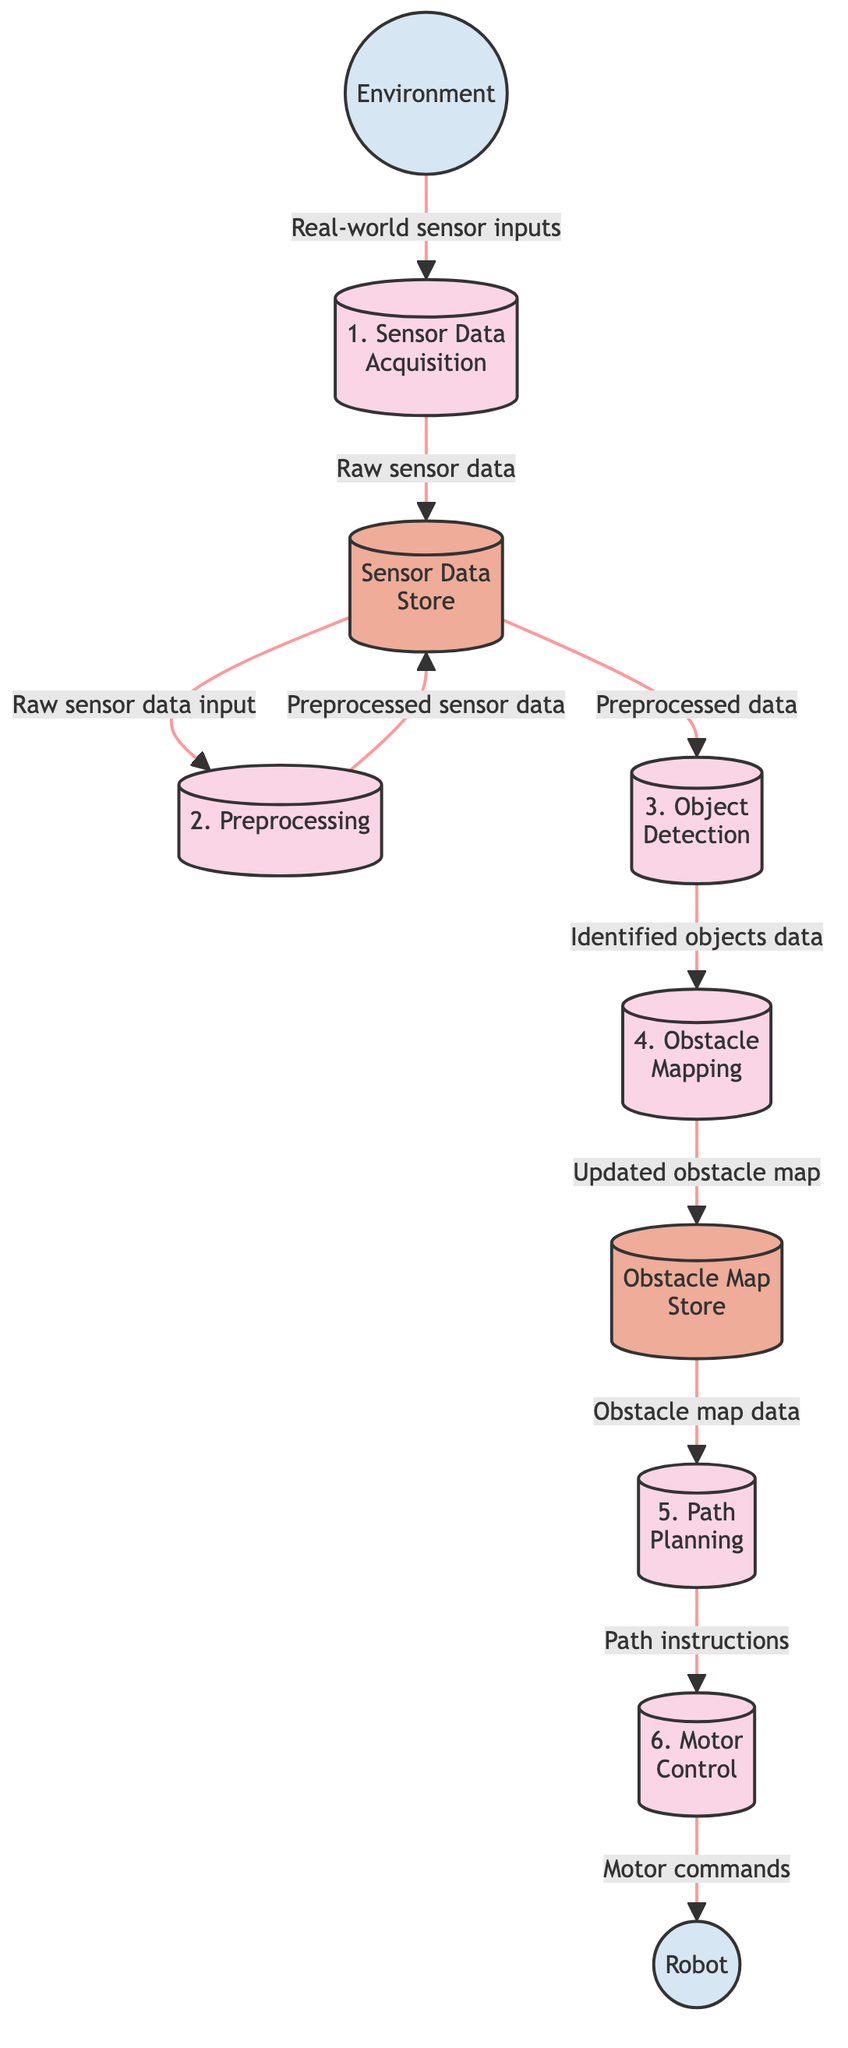What is the first process in the diagram? The first process in the diagram is labeled "1. Sensor Data Acquisition," which is indicated at the top of the processes section.
Answer: Sensor Data Acquisition How many processes are shown in the diagram? The diagram displays six processes: Sensor Data Acquisition, Preprocessing, Object Detection, Obstacle Mapping, Path Planning, and Motor Control, thus totaling six.
Answer: 6 What type of data does the Sensor Data Store hold? The Sensor Data Store holds both raw sensor data and preprocessed sensor data, as indicated by the connections from both the Sensor Data Acquisition and Preprocessing processes.
Answer: Raw and preprocessed sensor data Which external entity sends input to the first process? The Environment external entity sends real-world sensor inputs to the first process, Sensor Data Acquisition, as shown by the direct connection in the diagram.
Answer: Environment What is the output of the Object Detection process? The output of the Object Detection process is labeled as "Identified objects data," which is directed to the Obstacle Mapping process in the flow of the diagram.
Answer: Identified objects data What happens to the obstacle map after it is updated? After updating, the obstacle map is stored in the Obstacle Map Store, as indicated by the flow from the Obstacle Mapping process to the Obstacle Map Store.
Answer: Stored in the Obstacle Map Store Which process receives data from the Obstacle Map Store? The Path Planning process receives obstacle map data from the Obstacle Map Store, as clearly illustrated in the data flow from the store to this process.
Answer: Path Planning What command does the Motor Control process send to the Robot? The Motor Control process sends "Motor commands" to the Robot, which is represented by the final flow in the diagram.
Answer: Motor commands How does preprocessed sensor data return to the Sensor Data Store? Preprocessed sensor data is sent back to the Sensor Data Store from the Preprocessing process, as indicated by the data flow that loops back to the store.
Answer: Preprocessed sensor data output 